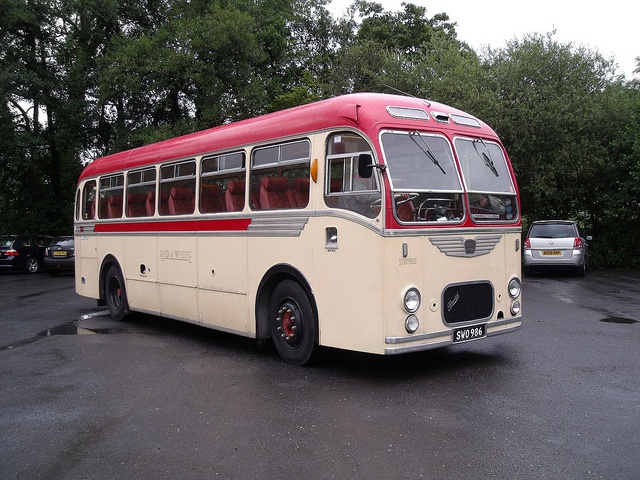Describe the objects in this image and their specific colors. I can see bus in darkgreen, lightgray, black, darkgray, and gray tones, truck in darkgreen, black, gray, darkgray, and lightgray tones, car in darkgreen, gray, black, darkgray, and lightgray tones, car in darkgreen, black, gray, brown, and darkgray tones, and car in darkgreen, black, gray, and darkgray tones in this image. 